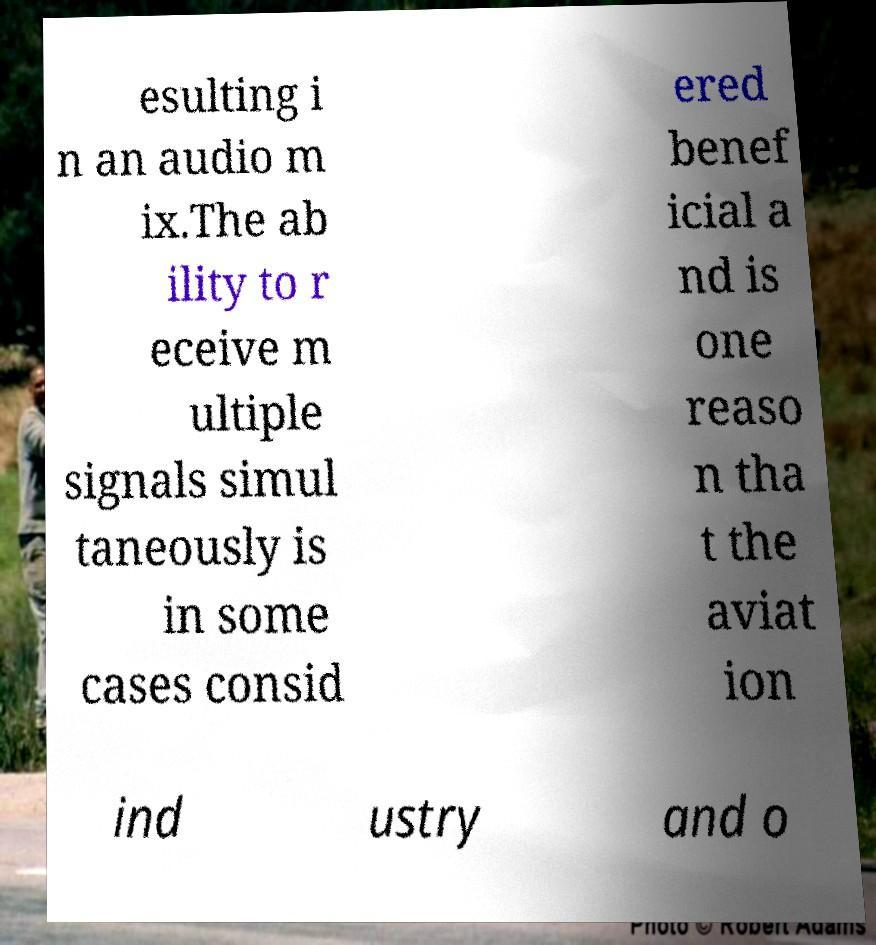Please read and relay the text visible in this image. What does it say? esulting i n an audio m ix.The ab ility to r eceive m ultiple signals simul taneously is in some cases consid ered benef icial a nd is one reaso n tha t the aviat ion ind ustry and o 